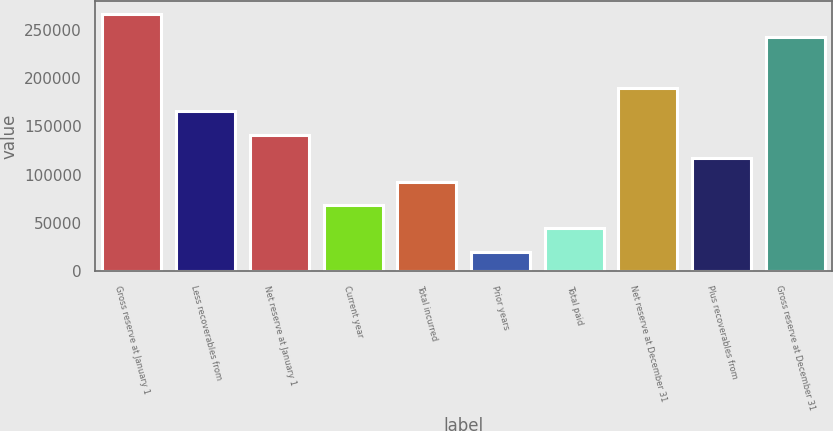Convert chart to OTSL. <chart><loc_0><loc_0><loc_500><loc_500><bar_chart><fcel>Gross reserve at January 1<fcel>Less recoverables from<fcel>Net reserve at January 1<fcel>Current year<fcel>Total incurred<fcel>Prior years<fcel>Total paid<fcel>Net reserve at December 31<fcel>Plus recoverables from<fcel>Gross reserve at December 31<nl><fcel>266784<fcel>165691<fcel>141422<fcel>68618.2<fcel>92886.3<fcel>20082<fcel>44350.1<fcel>189959<fcel>117154<fcel>242516<nl></chart> 